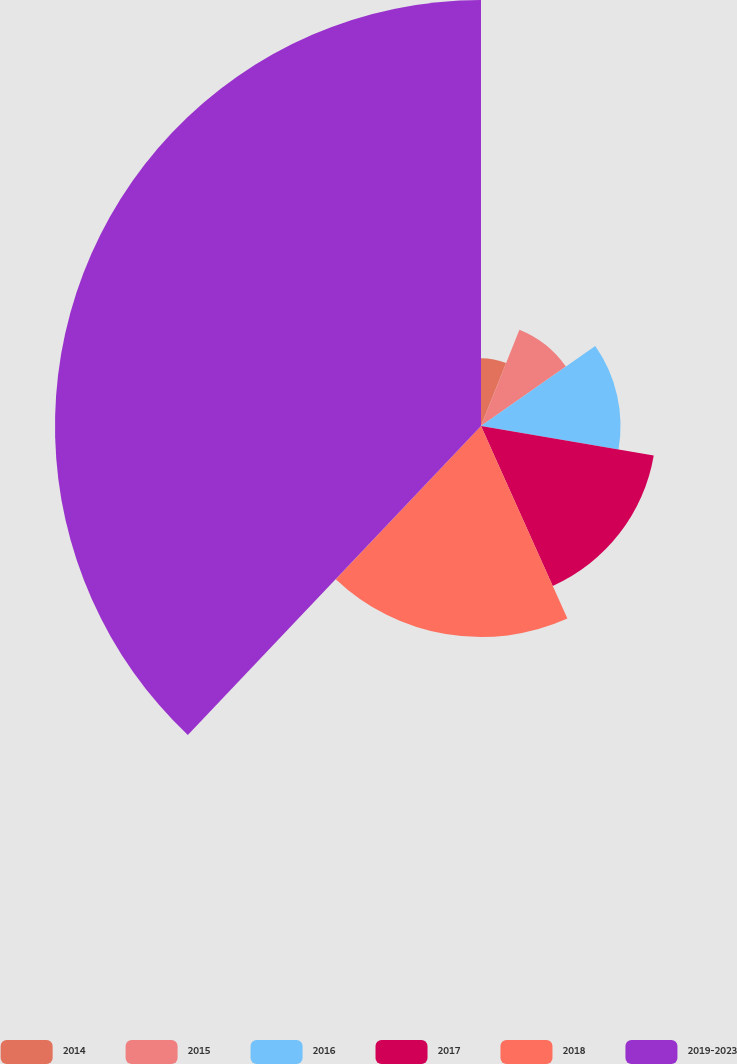Convert chart. <chart><loc_0><loc_0><loc_500><loc_500><pie_chart><fcel>2014<fcel>2015<fcel>2016<fcel>2017<fcel>2018<fcel>2019-2023<nl><fcel>6.04%<fcel>9.23%<fcel>12.42%<fcel>15.6%<fcel>18.79%<fcel>37.92%<nl></chart> 